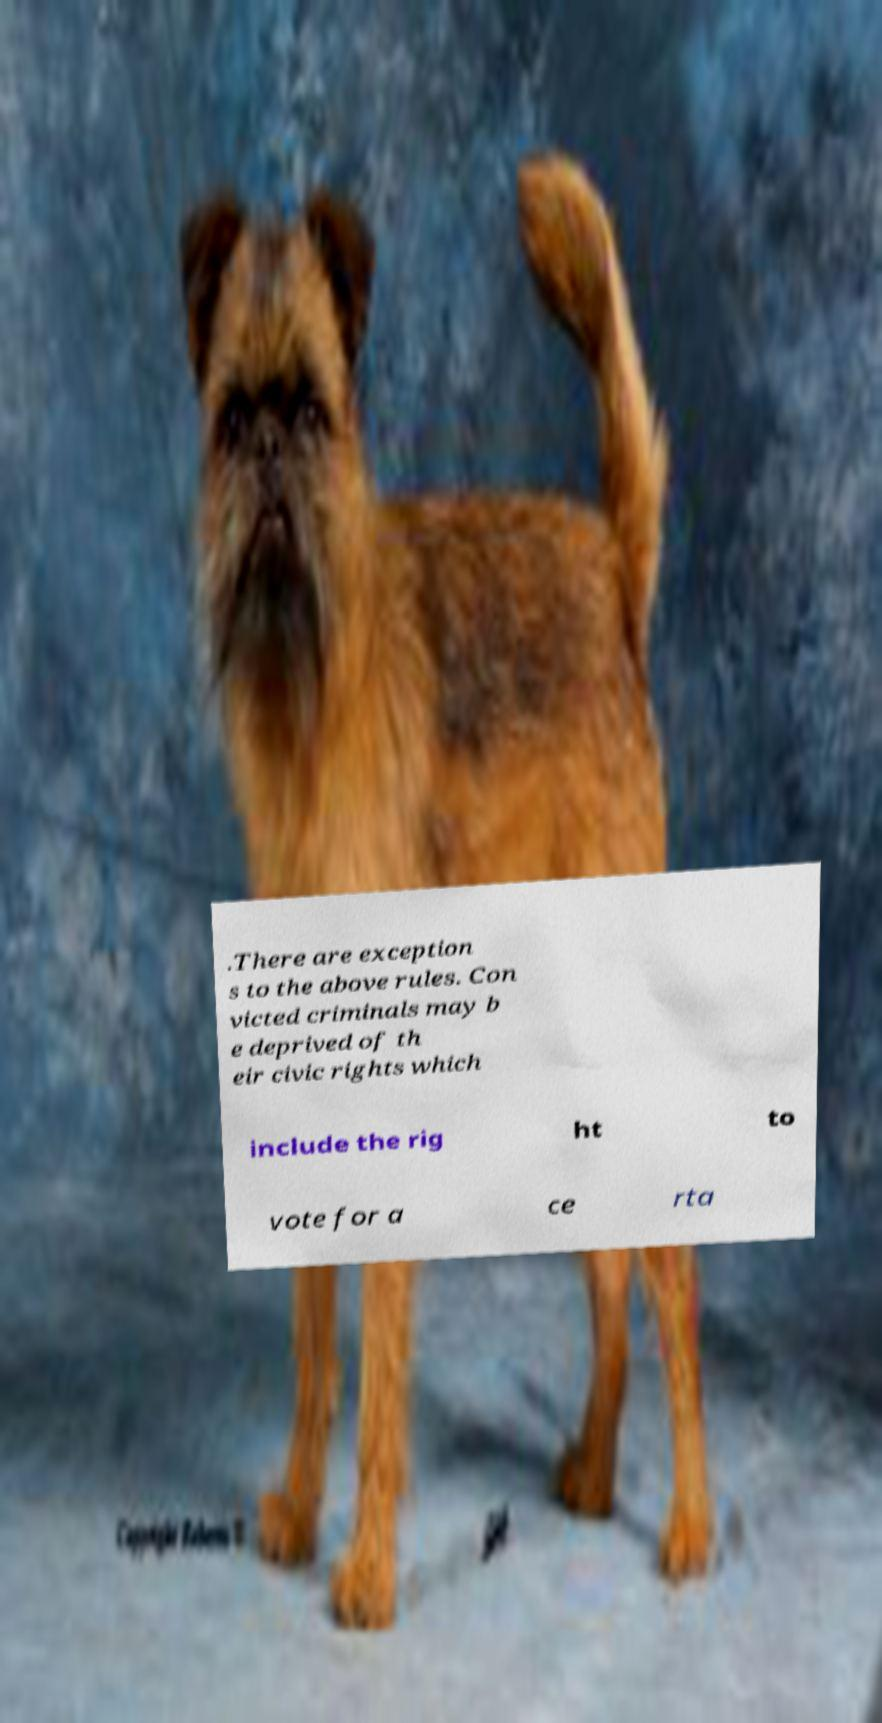Could you assist in decoding the text presented in this image and type it out clearly? .There are exception s to the above rules. Con victed criminals may b e deprived of th eir civic rights which include the rig ht to vote for a ce rta 